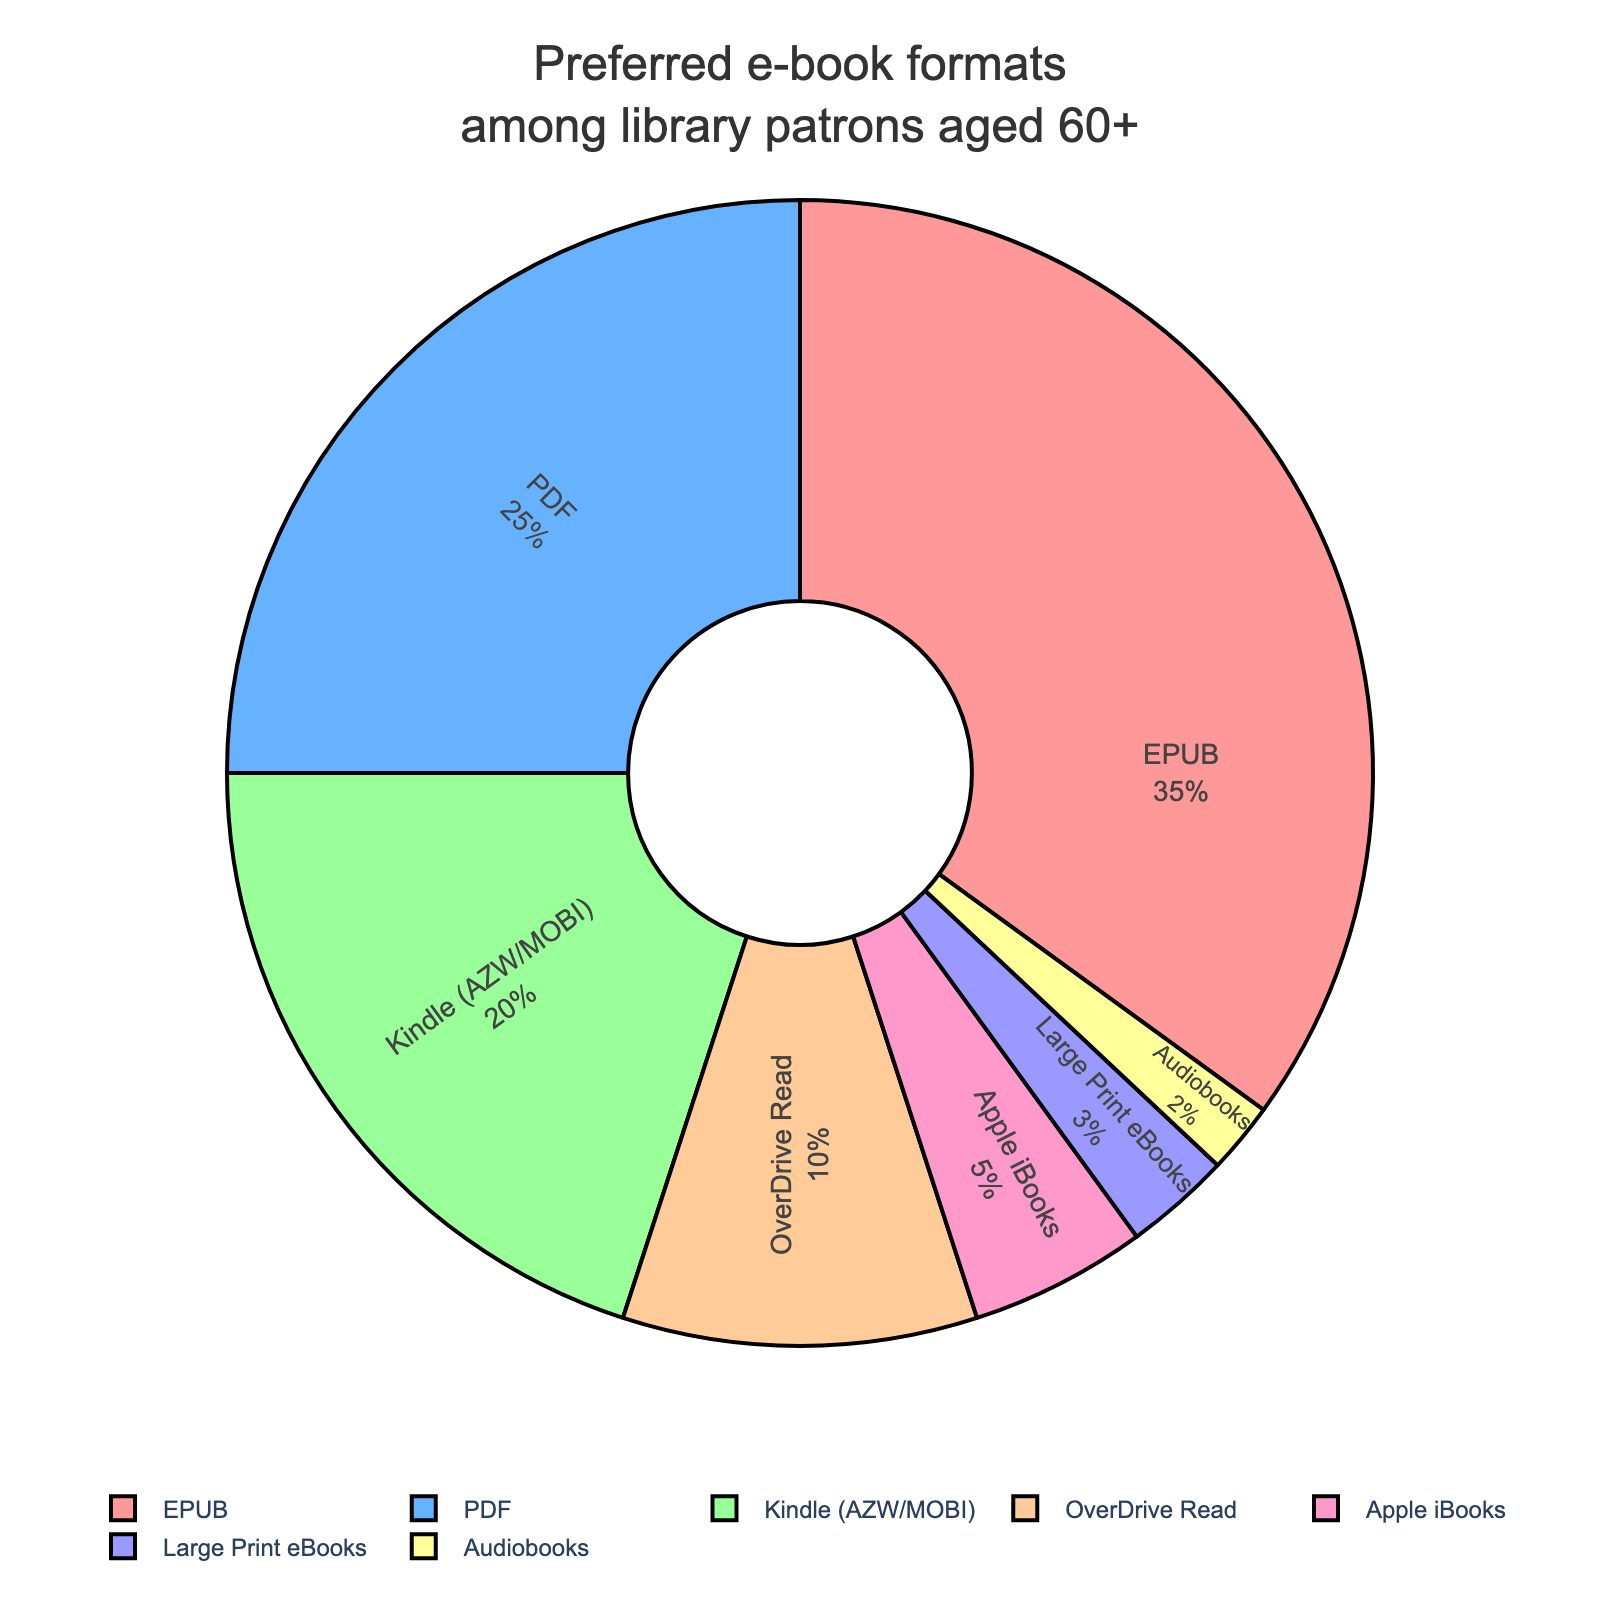What is the most preferred e-book format among library patrons aged 60+? The figure shows the percentages of different e-book formats preferred by library patrons aged 60+. The largest segment in the pie chart represents EPUB with 35%.
Answer: EPUB Which e-book format is the least preferred among the ones listed? By looking at the smallest segment in the pie chart, we can see that Audiobooks have the lowest percentage at 2%.
Answer: Audiobooks How much more popular is EPUB than Kindle (AZW/MOBI)? To find out how much more popular EPUB is compared to Kindle (AZW/MOBI), subtract the percentage of Kindle (AZW/MOBI) from the percentage of EPUB: (35% - 20% = 15%).
Answer: 15% What percentage of patrons prefer either PDF or Kindle (AZW/MOBI)? To find the combined percentage of patrons who prefer either PDF or Kindle (AZW/MOBI), add their percentages: (25% + 20% = 45%).
Answer: 45% Is OverDrive Read more popular than Apple iBooks among patrons aged 60+? By comparing the percentages, OverDrive Read has a higher percentage (10%) than Apple iBooks (5%).
Answer: Yes How do Audiobooks and Large Print eBooks together compare to the percentage of PDF? Add the percentages of Audiobooks and Large Print eBooks: (2% + 3% = 5%) and compare it to PDF's 25%. (5% < 25%).
Answer: Less preferred Among the listed formats, which one is preferred exactly half as much as the most preferred format? The most preferred format, EPUB, is at 35%. Half of 35% is 17.5%. Kindle (AZW/MOBI) has 20%, which is closest but not exactly half. No format is exactly half as preferred.
Answer: None exactly How many formats are preferred by at least 10% of the patrons? Look at the segments of the pie chart and count the formats that have 10% or more: (EPUB, PDF, and Kindle (AZW/MOBI), OverDrive Read). There are 4 formats.
Answer: 4 What is the combined percentage of formats preferred by less than 10% of the patrons? Sum the percentages of formats with less than 10%: (Apple iBooks 5% + Large Print eBooks 3% + Audiobooks 2% = 10%).
Answer: 10% If you combine PDF and Kindle (AZW/MOBI) preferences, what fraction of the total do they represent? Add the percentages of PDF and Kindle (AZW/MOBI): (25% + 20% = 45%). They represent 45% of the total, which is 45/100 or 9/20.
Answer: 9/20 